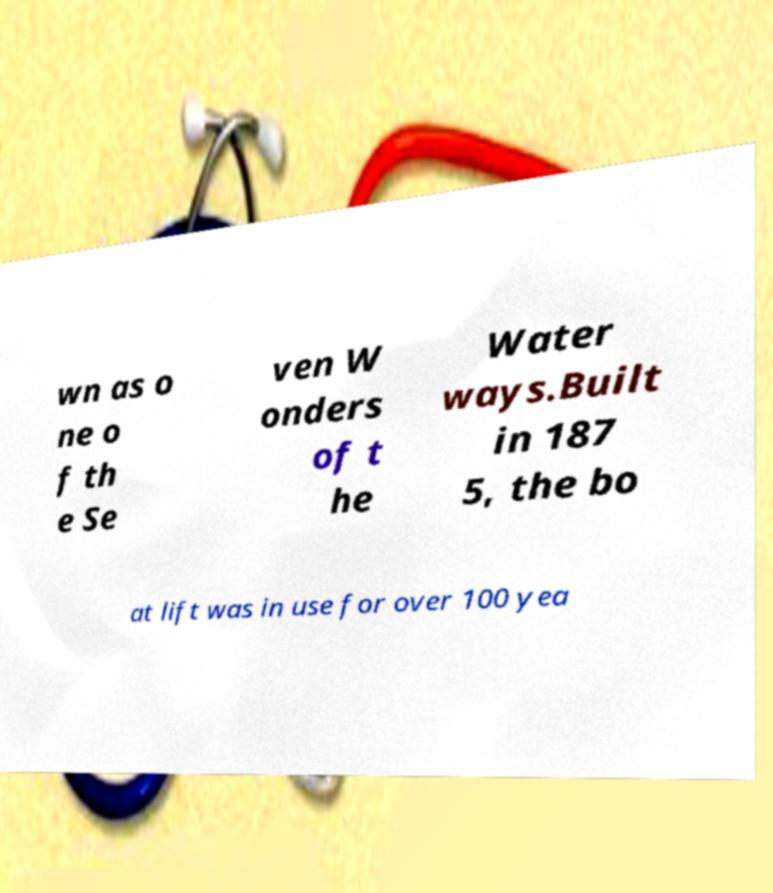For documentation purposes, I need the text within this image transcribed. Could you provide that? wn as o ne o f th e Se ven W onders of t he Water ways.Built in 187 5, the bo at lift was in use for over 100 yea 